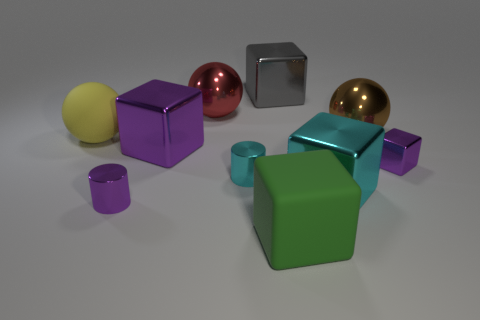There is a small block; does it have the same color as the block that is on the left side of the gray metal thing?
Your answer should be very brief. Yes. Are there any yellow shiny objects of the same shape as the big gray metal thing?
Your response must be concise. No. Does the tiny purple block have the same material as the large thing behind the red shiny object?
Give a very brief answer. Yes. The purple object that is to the left of the purple cube that is on the left side of the tiny shiny block is made of what material?
Offer a very short reply. Metal. Are there more purple metal blocks that are behind the cyan cylinder than brown balls?
Your response must be concise. Yes. Is there a large yellow metal cylinder?
Keep it short and to the point. No. There is a metal block behind the yellow rubber object; what is its color?
Your response must be concise. Gray. What material is the green cube that is the same size as the brown metallic sphere?
Keep it short and to the point. Rubber. How many other things are there of the same material as the big gray cube?
Offer a terse response. 7. What color is the metallic block that is both to the right of the gray metal block and to the left of the large brown sphere?
Offer a very short reply. Cyan. 